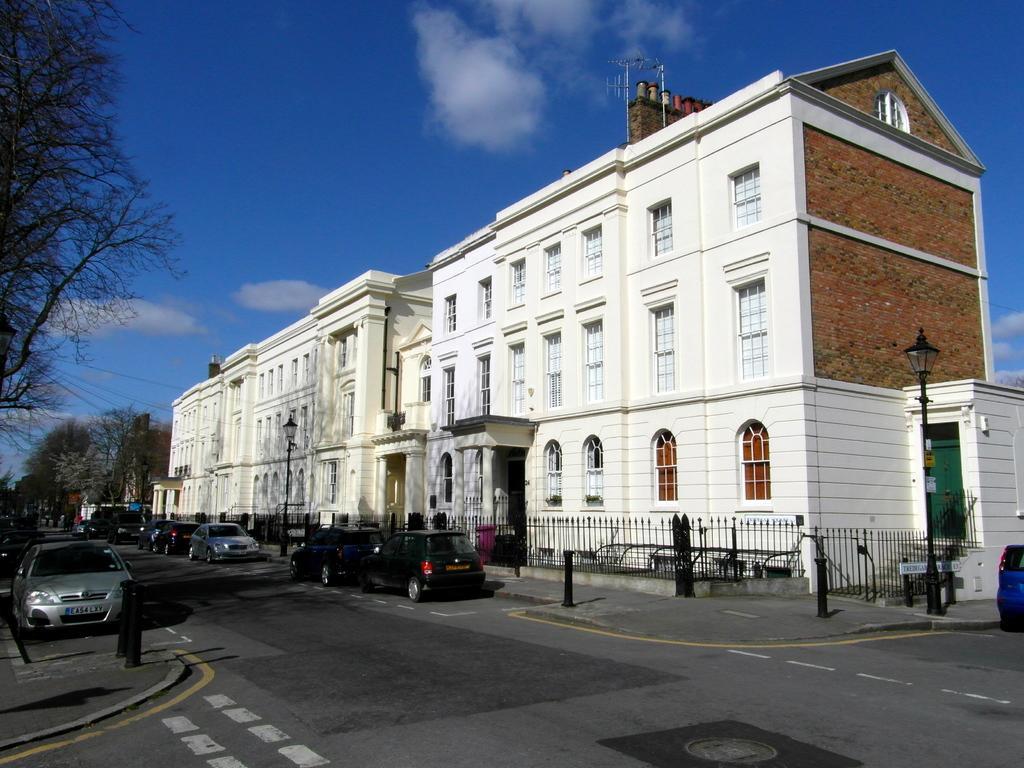Can you describe this image briefly? In this image I can see a building , in front of the building I can see car and fence visible on the road ,at the top I can see the sky ,on the left side I can see tree. 